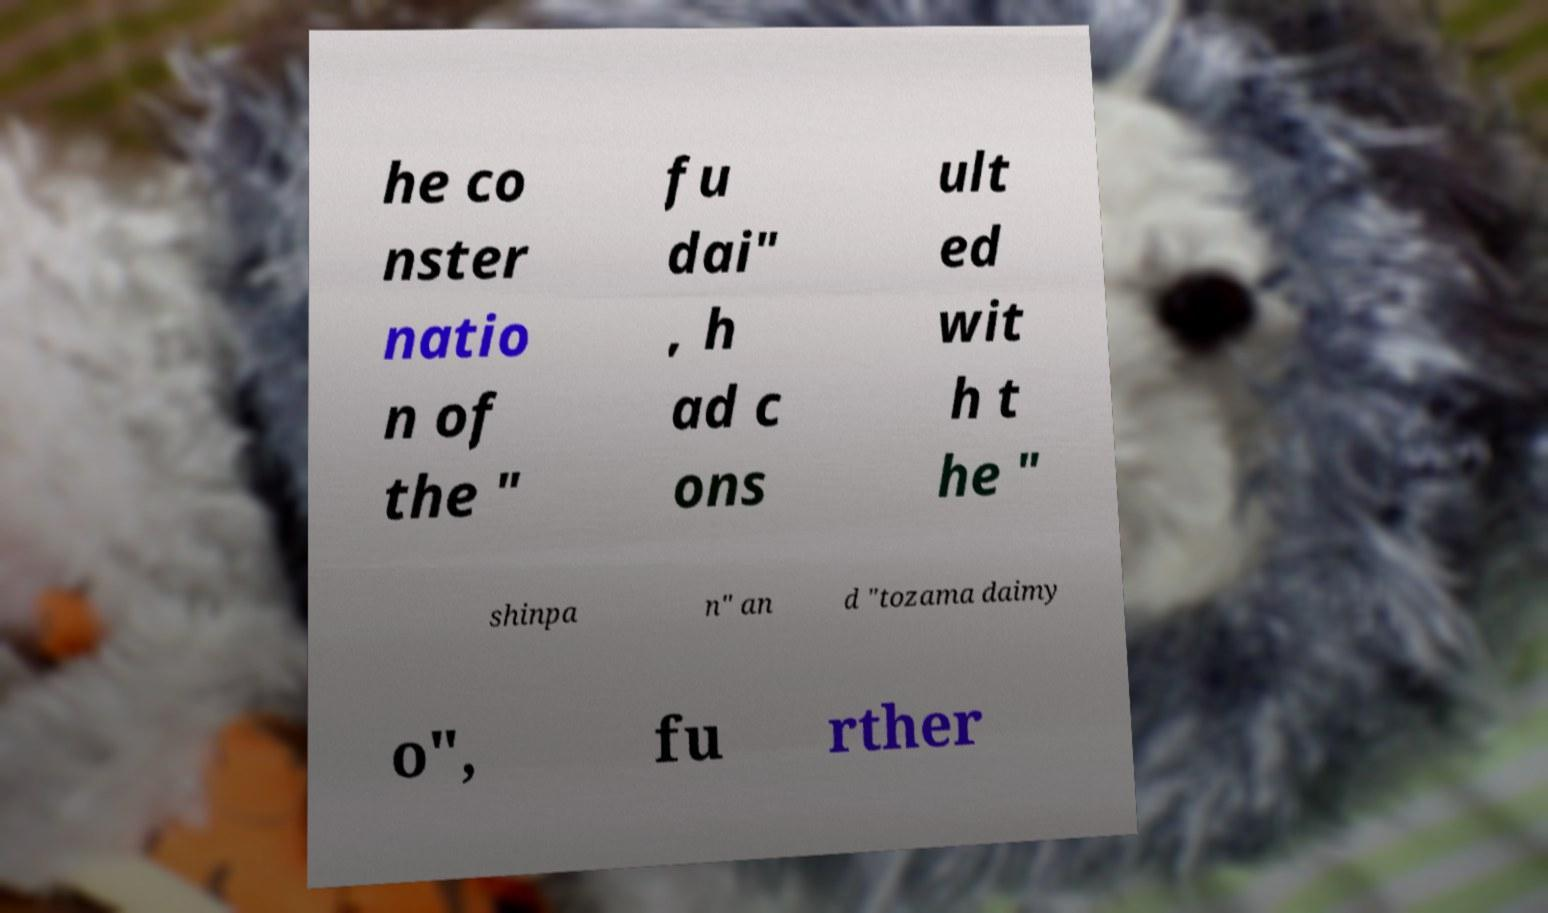There's text embedded in this image that I need extracted. Can you transcribe it verbatim? he co nster natio n of the " fu dai" , h ad c ons ult ed wit h t he " shinpa n" an d "tozama daimy o", fu rther 